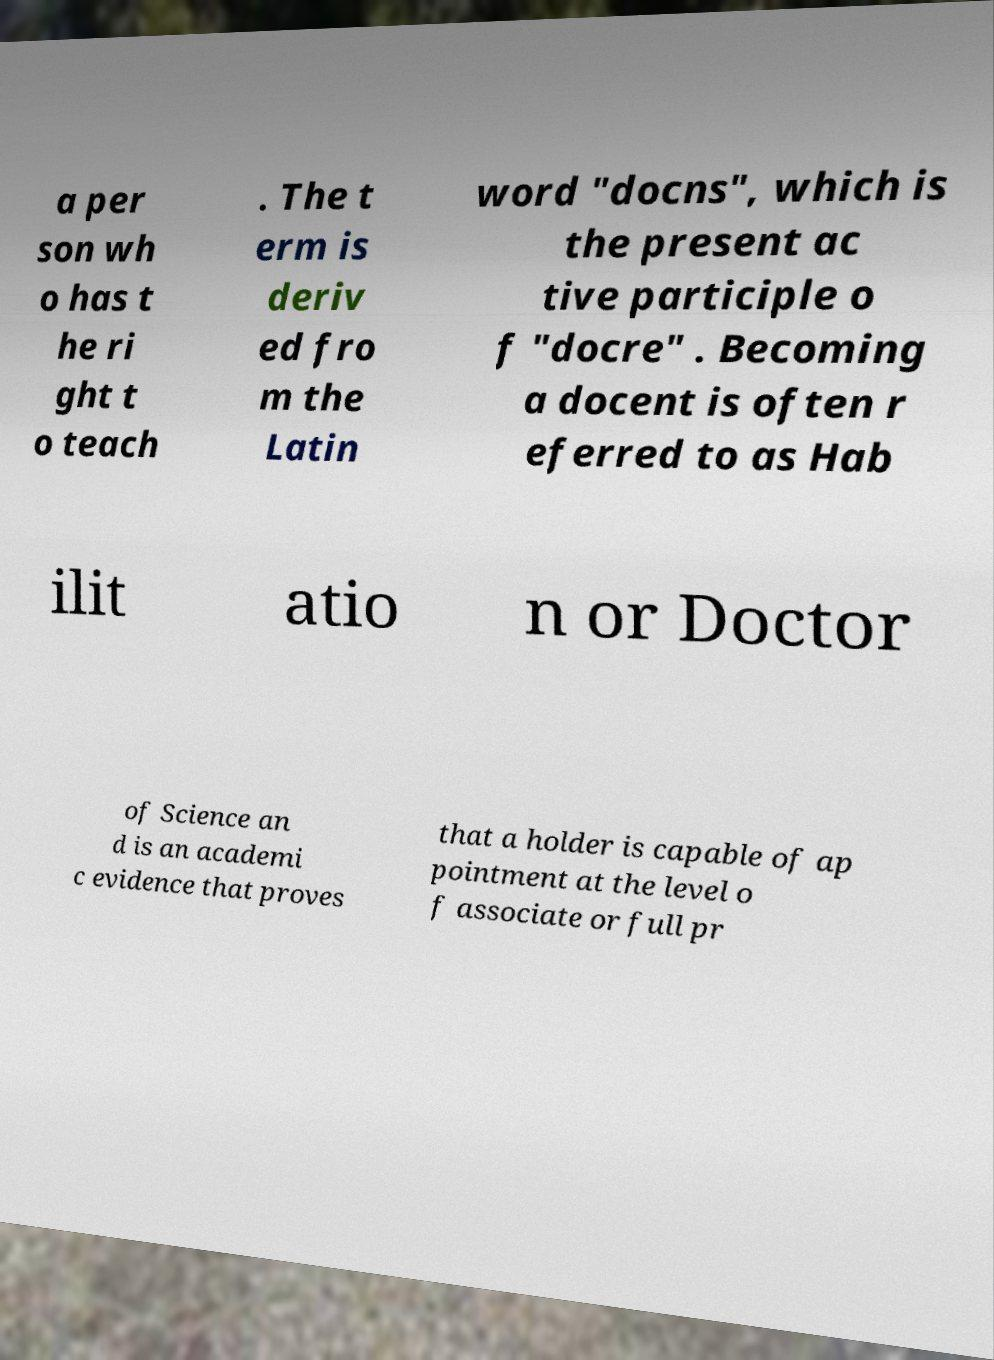There's text embedded in this image that I need extracted. Can you transcribe it verbatim? a per son wh o has t he ri ght t o teach . The t erm is deriv ed fro m the Latin word "docns", which is the present ac tive participle o f "docre" . Becoming a docent is often r eferred to as Hab ilit atio n or Doctor of Science an d is an academi c evidence that proves that a holder is capable of ap pointment at the level o f associate or full pr 